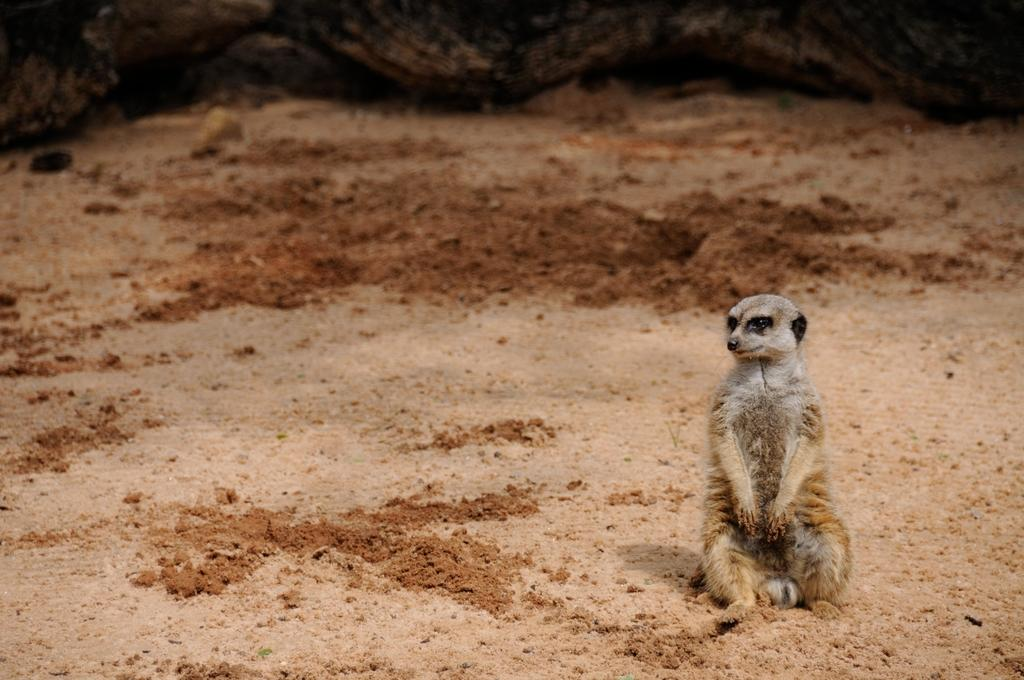What type of creature is present in the image? There is an animal in the image. Can you describe the position of the animal in the image? The animal is sitting on the ground. What type of shock can be seen affecting the animal in the image? There is no shock present in the image; the animal is simply sitting on the ground. How many pizzas are visible in the image? There are no pizzas present in the image. 